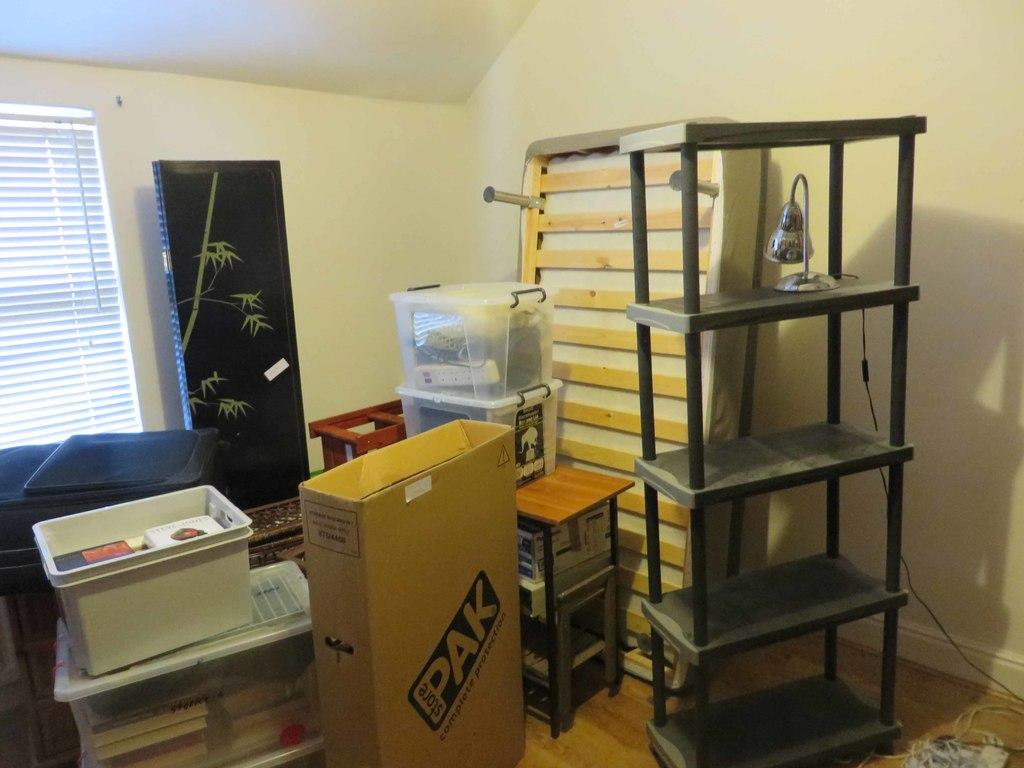<image>
Offer a succinct explanation of the picture presented. a brown box with the word pak on it 